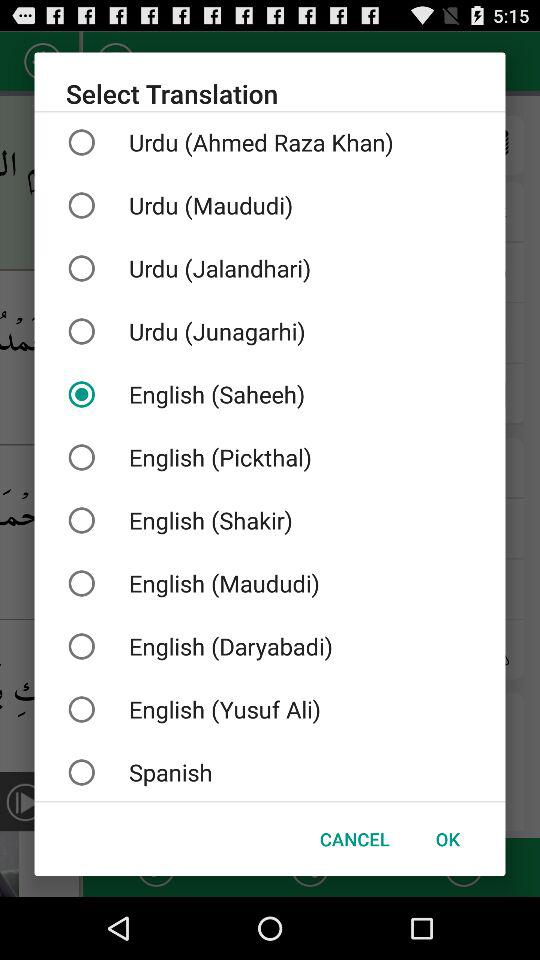Which are the different translations? The different translations are "Urdu (Ahmed Raza Khan)", "Urdu (Maududi)", "Urdu (Jalandhari)", "Urdu (Junagarhi)", "English (Saheeh)", "English (Pickthal)", "English (Shakir)", "English (Maududi)", "English (Daryabadi)", "English (Yusuf Ali)", and " Spanish". 